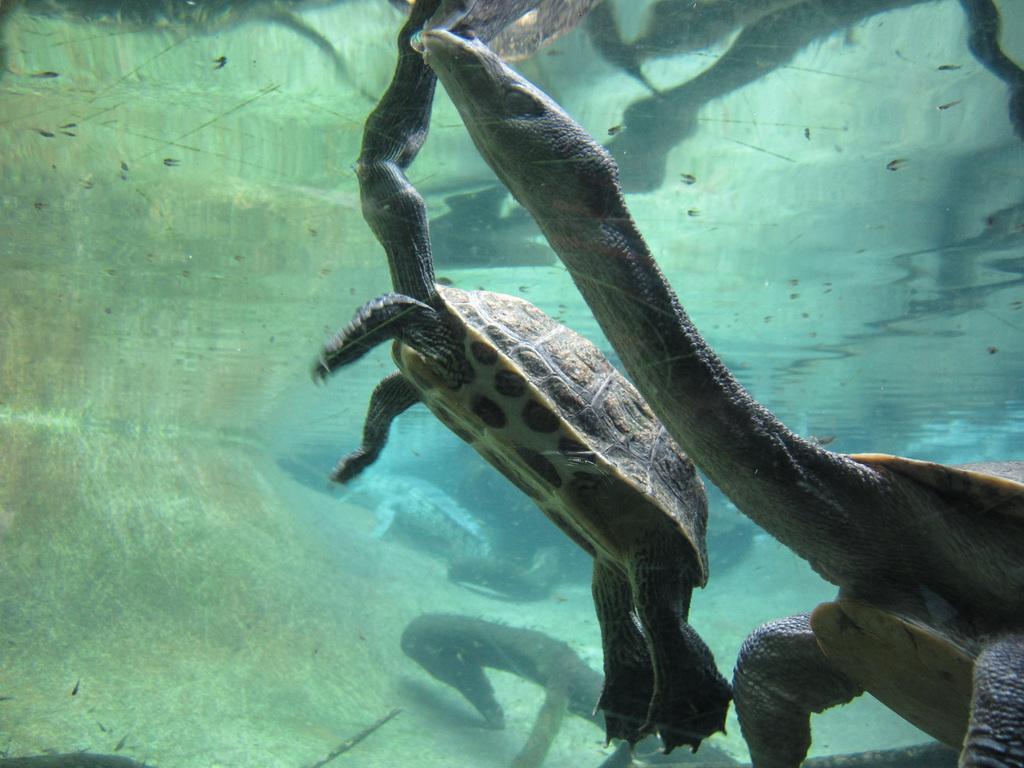Could you give a brief overview of what you see in this image? In the foreground I can see four tortoises in the water. This image is taken may be in the ocean. 